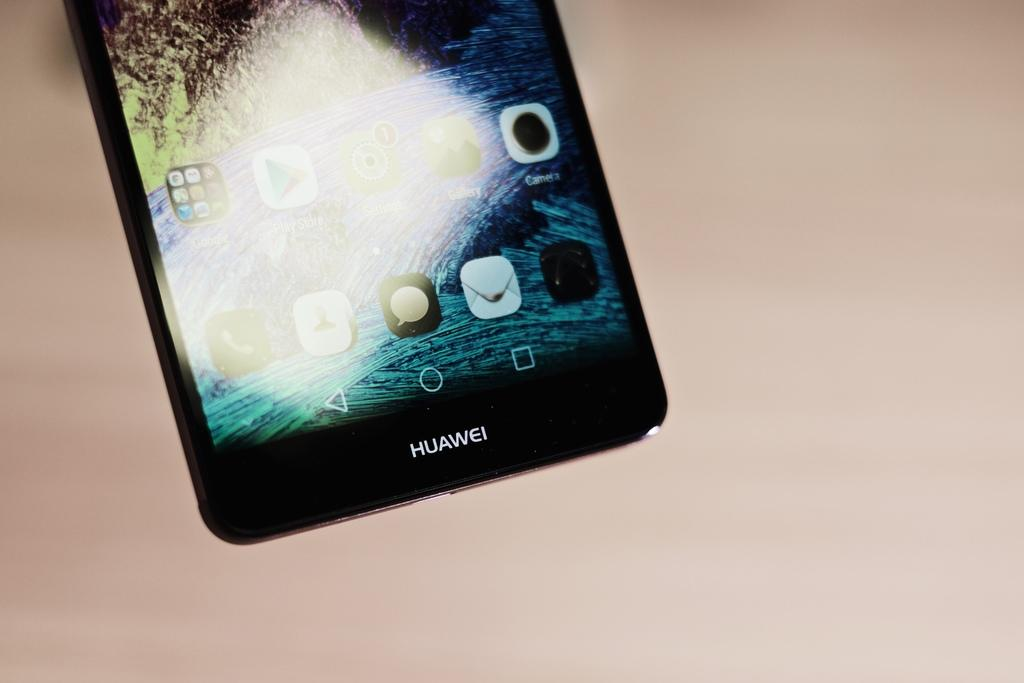<image>
Present a compact description of the photo's key features. The bottom of a Huawei phone has a black frame with white lettering. 